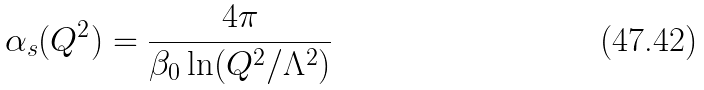Convert formula to latex. <formula><loc_0><loc_0><loc_500><loc_500>\alpha _ { s } ( Q ^ { 2 } ) = \frac { 4 \pi } { \beta _ { 0 } \ln ( Q ^ { 2 } / \Lambda ^ { 2 } ) }</formula> 